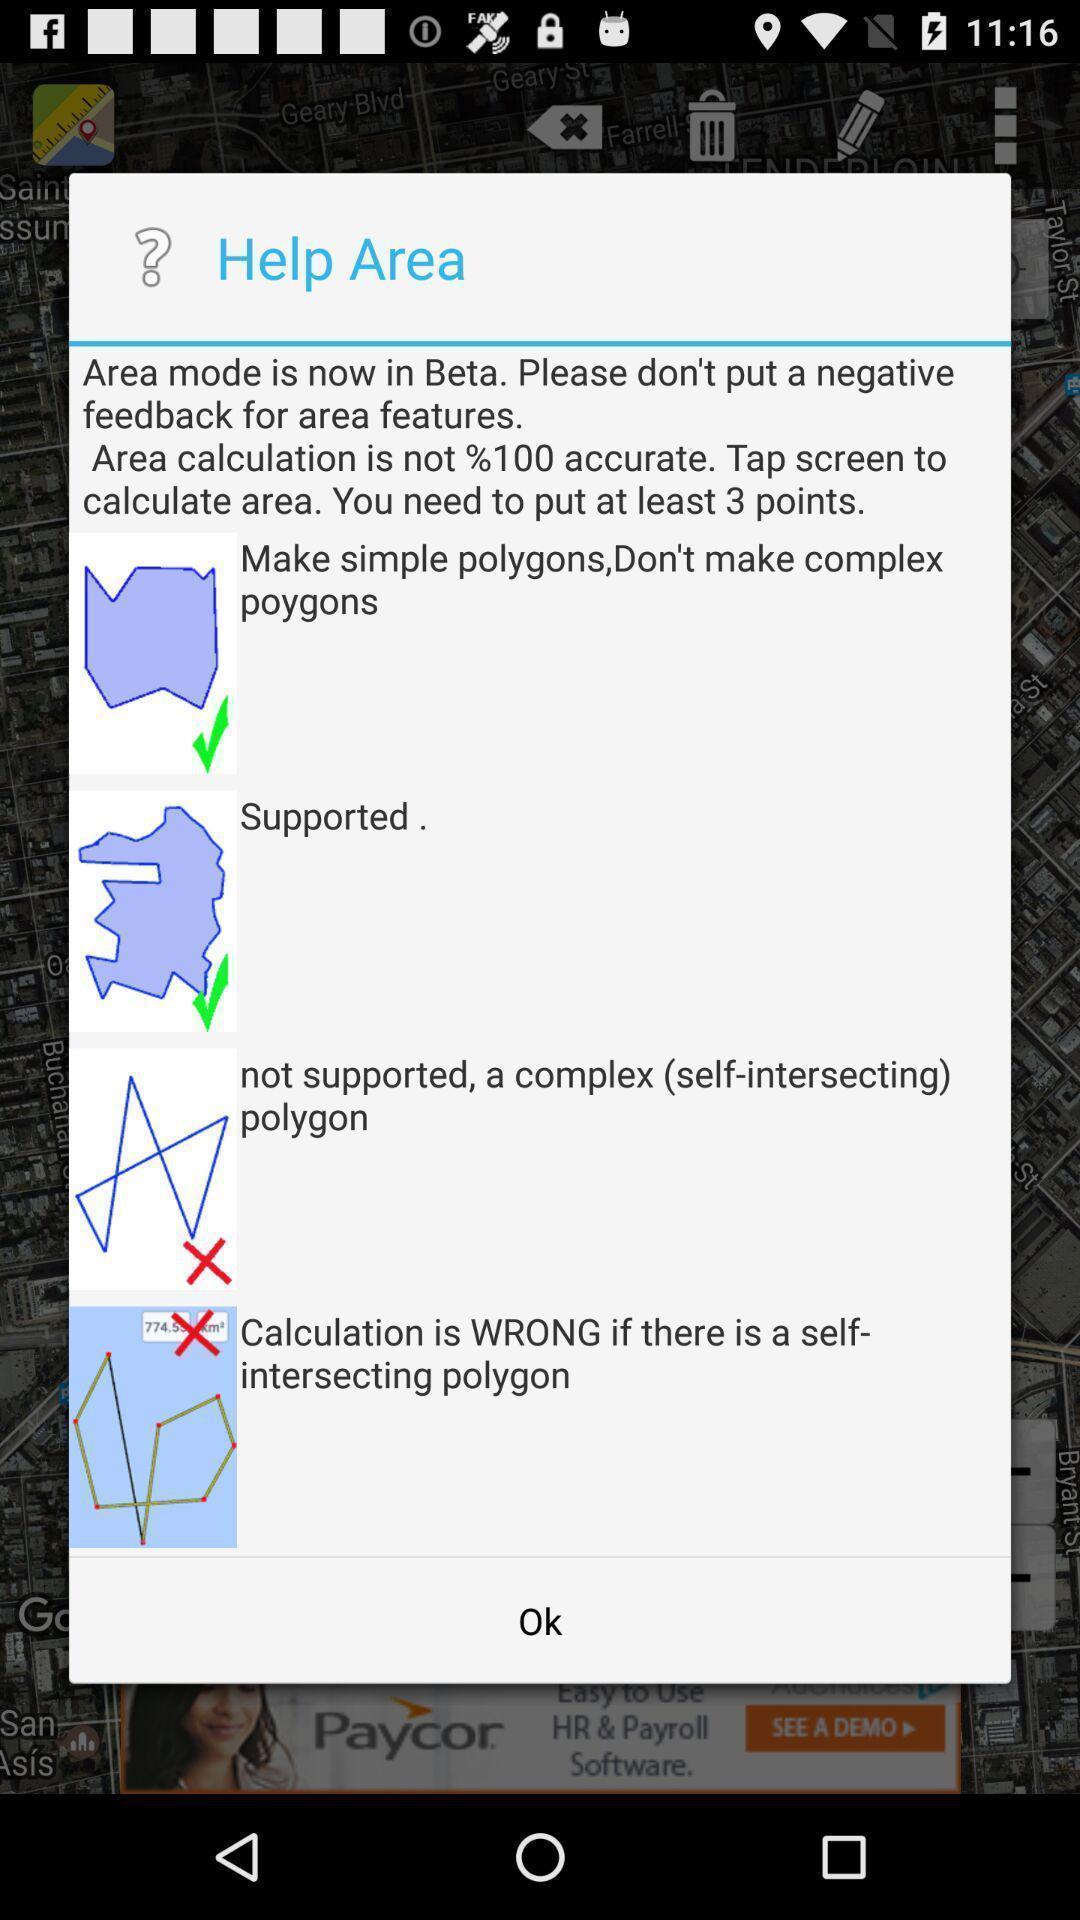Explain the elements present in this screenshot. Pop-up showing help area option. 